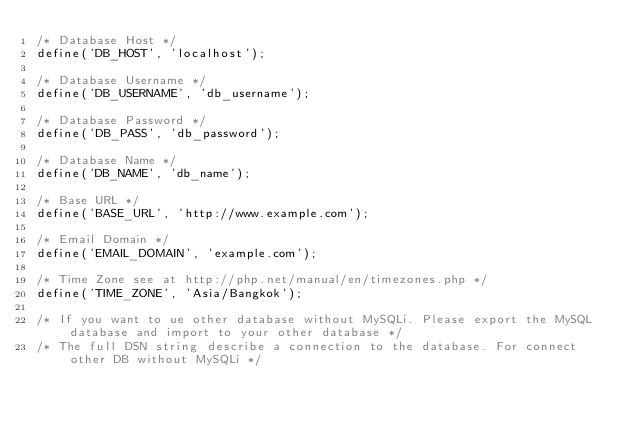<code> <loc_0><loc_0><loc_500><loc_500><_PHP_>/* Database Host */
define('DB_HOST', 'localhost');

/* Database Username */
define('DB_USERNAME', 'db_username');

/* Database Password */
define('DB_PASS', 'db_password');

/* Database Name */
define('DB_NAME', 'db_name');

/* Base URL */
define('BASE_URL', 'http://www.example.com');

/* Email Domain */
define('EMAIL_DOMAIN', 'example.com');

/* Time Zone see at http://php.net/manual/en/timezones.php */
define('TIME_ZONE', 'Asia/Bangkok');

/* If you want to ue other database without MySQLi. Please export the MySQL database and import to your other database */
/* The full DSN string describe a connection to the database. For connect other DB without MySQLi */</code> 